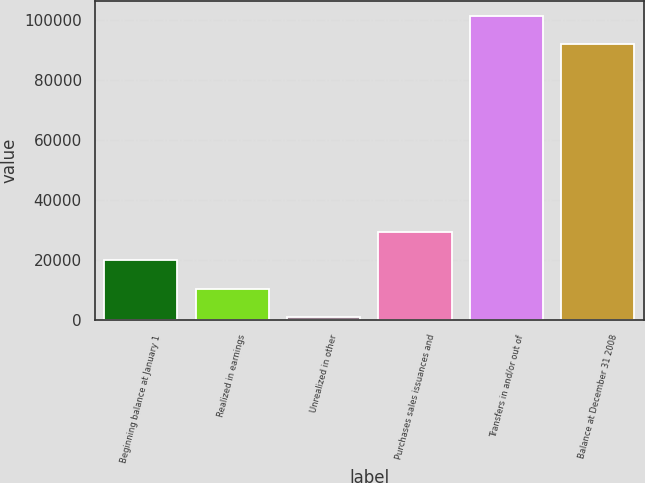Convert chart. <chart><loc_0><loc_0><loc_500><loc_500><bar_chart><fcel>Beginning balance at January 1<fcel>Realized in earnings<fcel>Unrealized in other<fcel>Purchases sales issuances and<fcel>Transfers in and/or out of<fcel>Balance at December 31 2008<nl><fcel>19968.6<fcel>10524.3<fcel>1080<fcel>29412.9<fcel>101370<fcel>91926<nl></chart> 